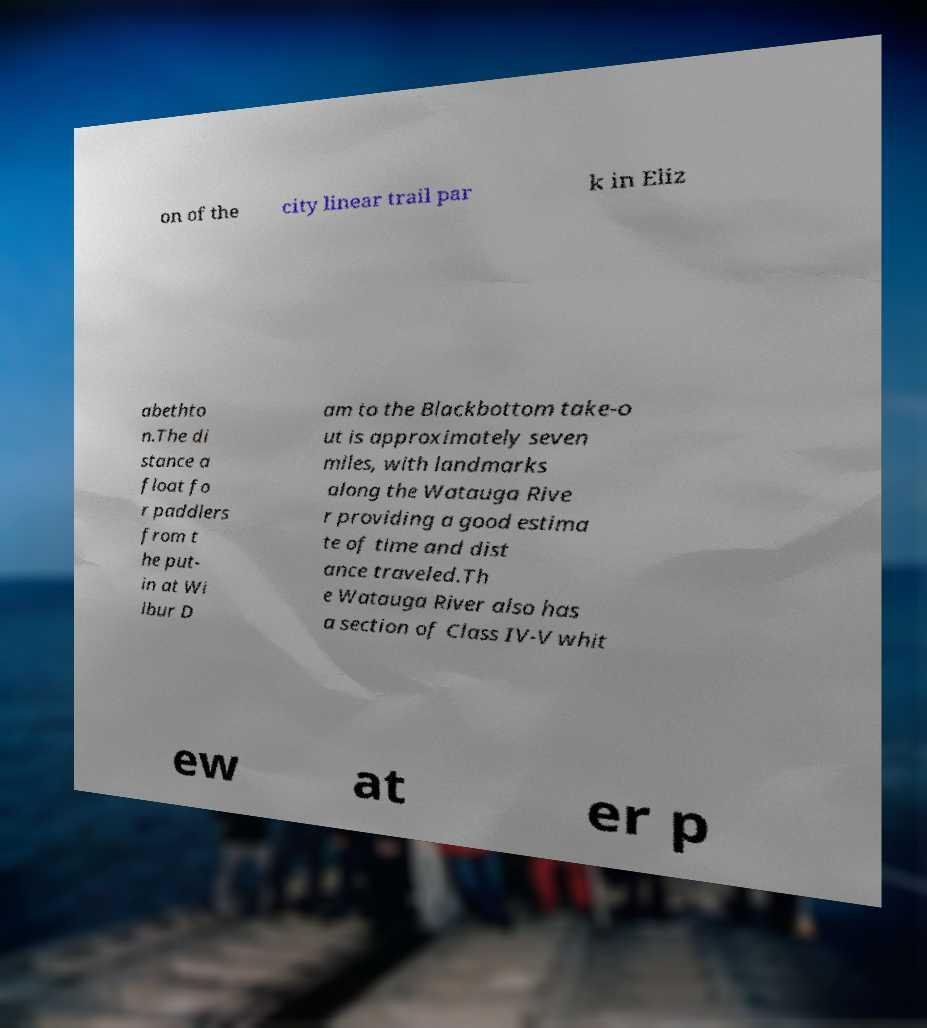What messages or text are displayed in this image? I need them in a readable, typed format. on of the city linear trail par k in Eliz abethto n.The di stance a float fo r paddlers from t he put- in at Wi lbur D am to the Blackbottom take-o ut is approximately seven miles, with landmarks along the Watauga Rive r providing a good estima te of time and dist ance traveled.Th e Watauga River also has a section of Class IV-V whit ew at er p 